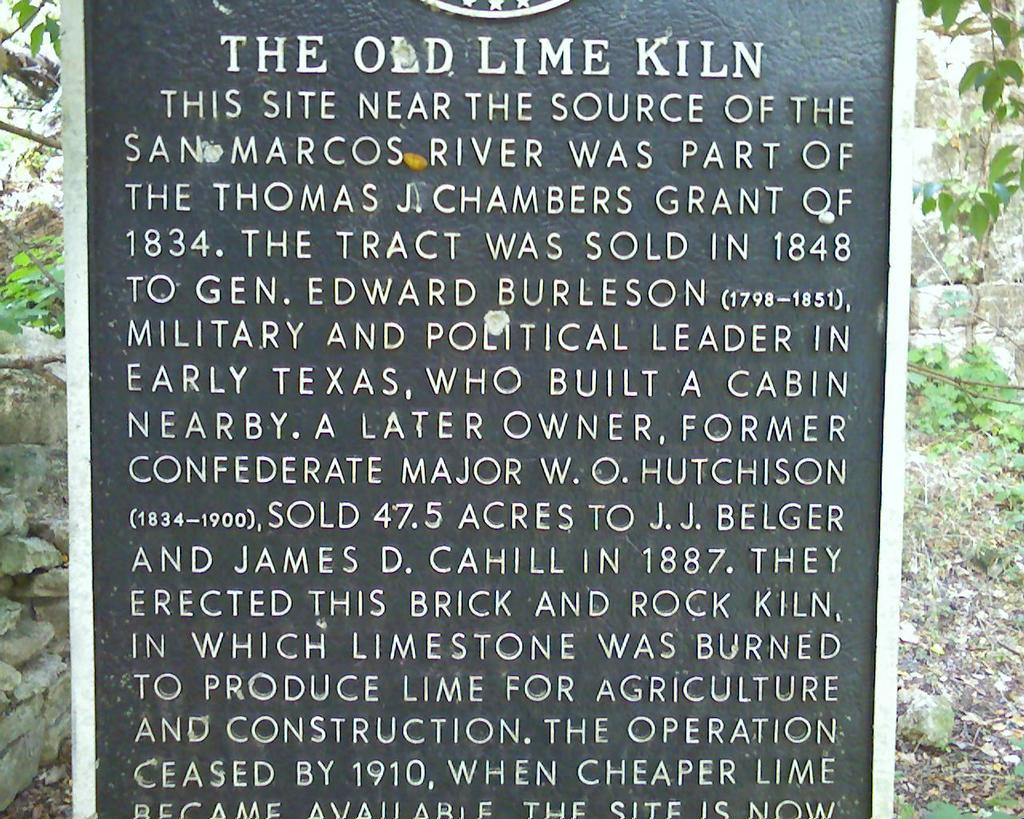What is the main subject in the foreground of the image? There is a cornerstone in the foreground of the image. What can be seen on the left side of the image? There are stones and trees on the left side of the image. What is present on the right side of the image? There is dry grass, plants, stones, and trees on the right side of the image. Can you tell me how many kitties are playing with a box in the image? There are no kitties or boxes present in the image. What type of account is mentioned in the image? There is no mention of any account in the image. 